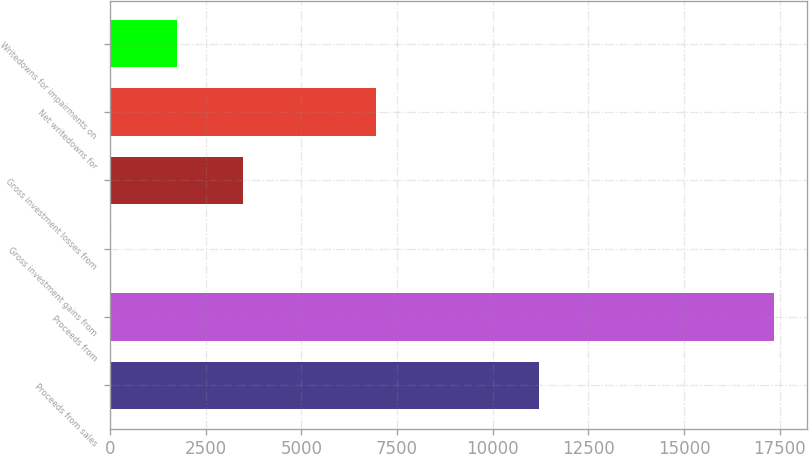Convert chart to OTSL. <chart><loc_0><loc_0><loc_500><loc_500><bar_chart><fcel>Proceeds from sales<fcel>Proceeds from<fcel>Gross investment gains from<fcel>Gross investment losses from<fcel>Net writedowns for<fcel>Writedowns for impairments on<nl><fcel>11214<fcel>17346<fcel>3.18<fcel>3471.74<fcel>6940.3<fcel>1737.46<nl></chart> 